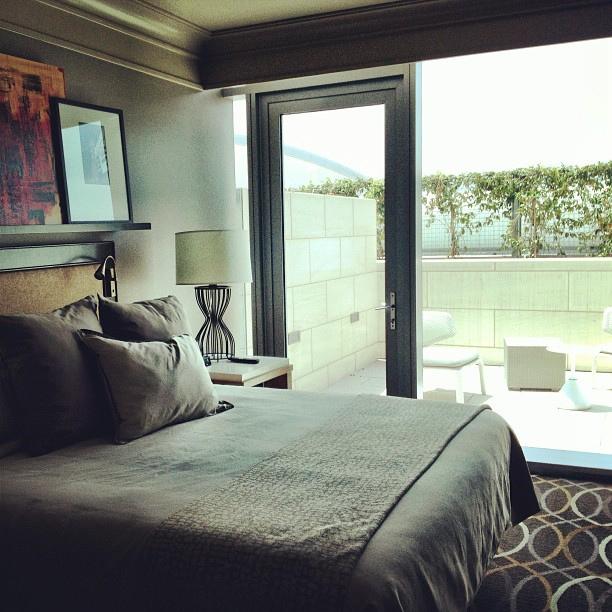Is the bed made?
Give a very brief answer. Yes. Is the patio private?
Short answer required. Yes. Is this place expensive?
Be succinct. Yes. Does the bed look comfy?
Concise answer only. Yes. What room is this?
Be succinct. Bedroom. How many people are laying down?
Be succinct. 0. What season is it?
Quick response, please. Summer. 